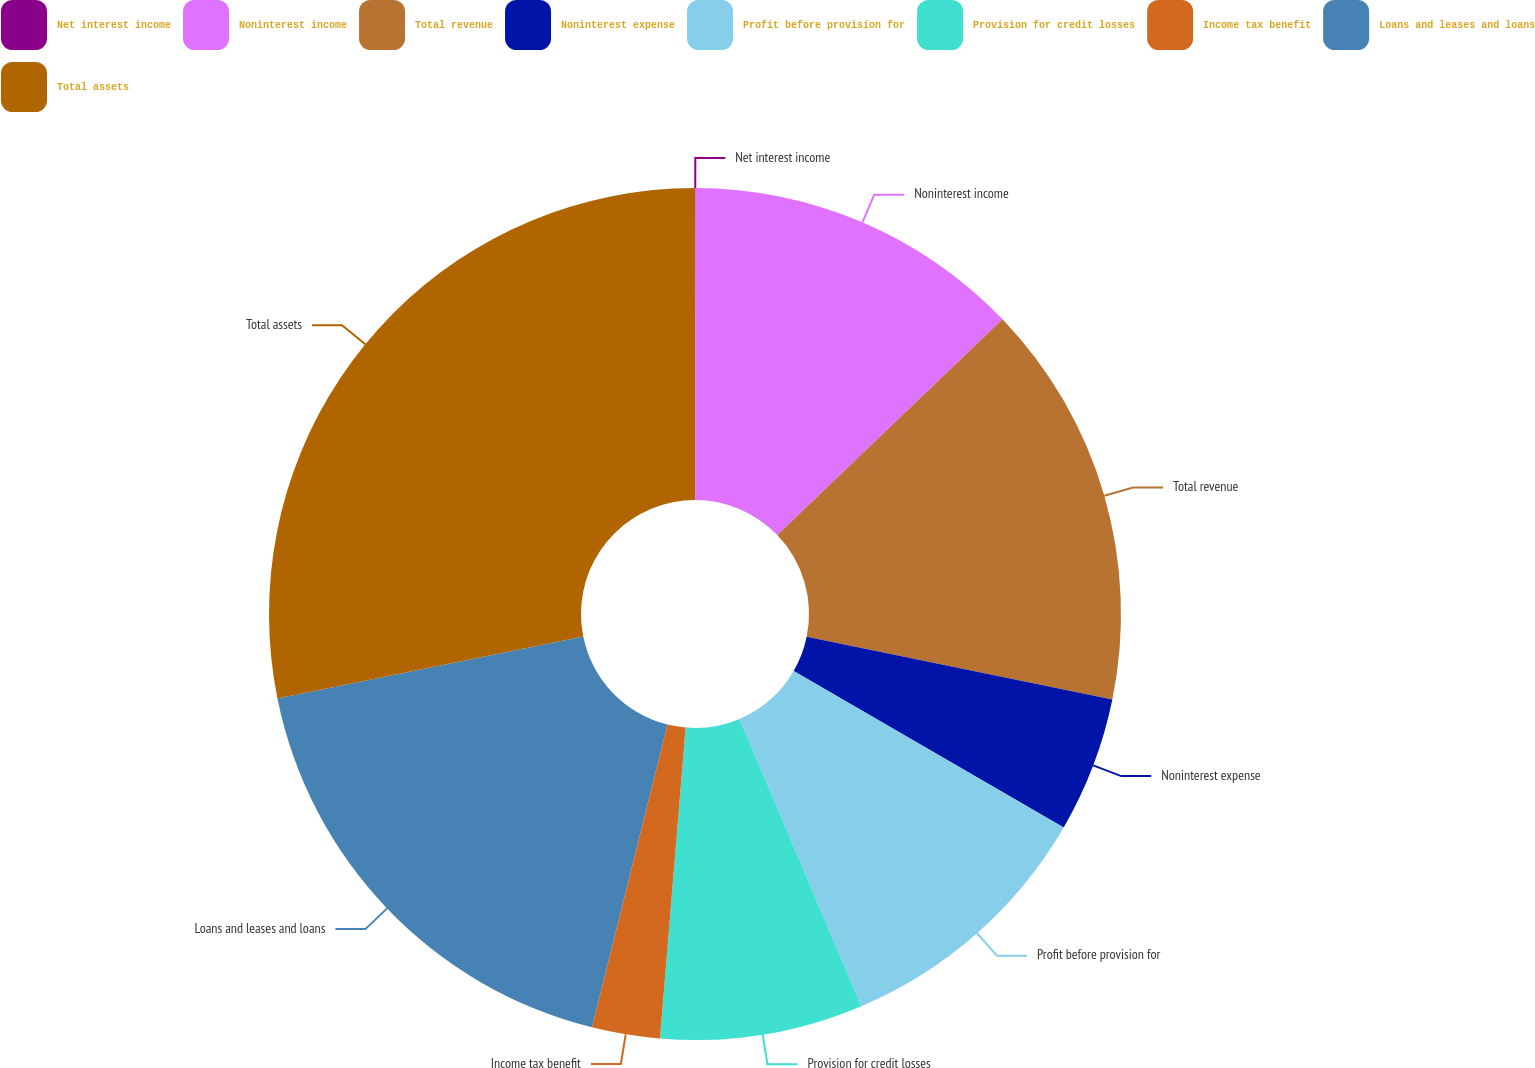Convert chart. <chart><loc_0><loc_0><loc_500><loc_500><pie_chart><fcel>Net interest income<fcel>Noninterest income<fcel>Total revenue<fcel>Noninterest expense<fcel>Profit before provision for<fcel>Provision for credit losses<fcel>Income tax benefit<fcel>Loans and leases and loans<fcel>Total assets<nl><fcel>0.02%<fcel>12.82%<fcel>15.38%<fcel>5.14%<fcel>10.26%<fcel>7.7%<fcel>2.58%<fcel>17.94%<fcel>28.18%<nl></chart> 